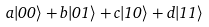<formula> <loc_0><loc_0><loc_500><loc_500>a | 0 0 \rangle + b | 0 1 \rangle + c | 1 0 \rangle + d | 1 1 \rangle</formula> 